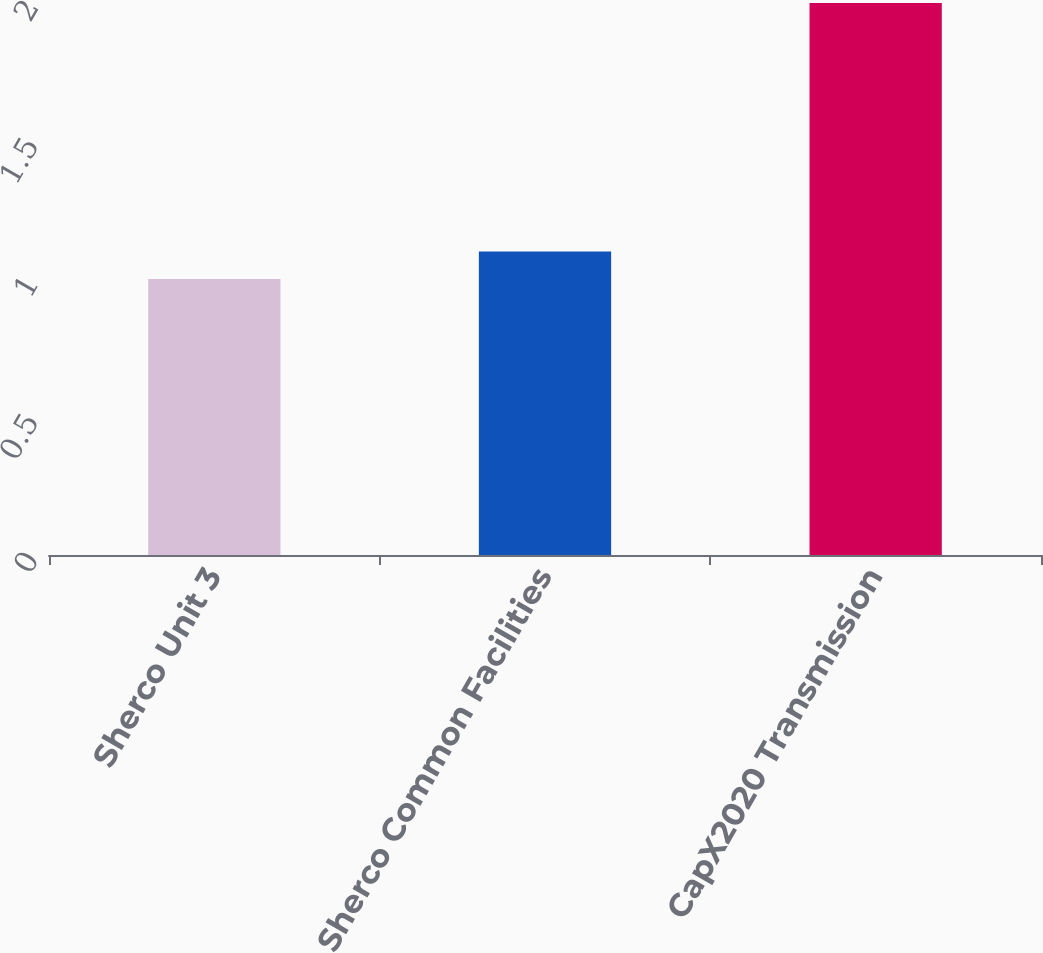<chart> <loc_0><loc_0><loc_500><loc_500><bar_chart><fcel>Sherco Unit 3<fcel>Sherco Common Facilities<fcel>CapX2020 Transmission<nl><fcel>1<fcel>1.1<fcel>2<nl></chart> 